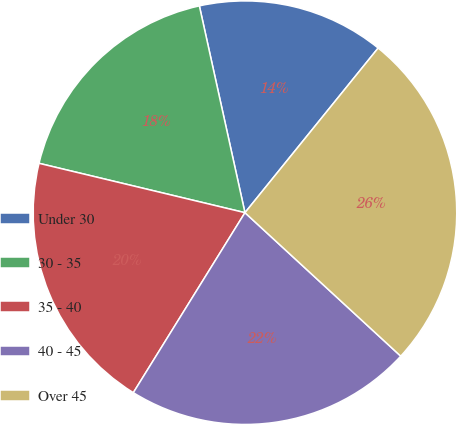<chart> <loc_0><loc_0><loc_500><loc_500><pie_chart><fcel>Under 30<fcel>30 - 35<fcel>35 - 40<fcel>40 - 45<fcel>Over 45<nl><fcel>14.28%<fcel>17.8%<fcel>19.91%<fcel>21.99%<fcel>26.02%<nl></chart> 